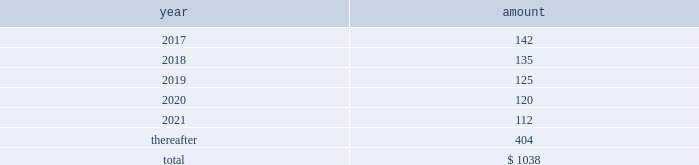Future payments that will not be paid because of an early redemption , which is discounted at a fixed spread over a comparable treasury security .
The unamortized discount and debt issuance costs are being amortized over the remaining term of the 2022 notes .
2021 notes .
In may 2011 , the company issued $ 1.5 billion in aggregate principal amount of unsecured unsubordinated obligations .
These notes were issued as two separate series of senior debt securities , including $ 750 million of 4.25% ( 4.25 % ) notes maturing in may 2021 and $ 750 million of floating rate notes , which were repaid in may 2013 at maturity .
Net proceeds of this offering were used to fund the repurchase of blackrock 2019s series b preferred from affiliates of merrill lynch & co. , inc .
Interest on the 4.25% ( 4.25 % ) notes due in 2021 ( 201c2021 notes 201d ) is payable semi-annually on may 24 and november 24 of each year , which commenced november 24 , 2011 , and is approximately $ 32 million per year .
The 2021 notes may be redeemed prior to maturity at any time in whole or in part at the option of the company at a 201cmake-whole 201d redemption price .
The unamortized discount and debt issuance costs are being amortized over the remaining term of the 2021 notes .
2019 notes .
In december 2009 , the company issued $ 2.5 billion in aggregate principal amount of unsecured and unsubordinated obligations .
These notes were issued as three separate series of senior debt securities including $ 0.5 billion of 2.25% ( 2.25 % ) notes , which were repaid in december 2012 , $ 1.0 billion of 3.50% ( 3.50 % ) notes , which were repaid in december 2014 at maturity , and $ 1.0 billion of 5.0% ( 5.0 % ) notes maturing in december 2019 ( the 201c2019 notes 201d ) .
Net proceeds of this offering were used to repay borrowings under the cp program , which was used to finance a portion of the acquisition of barclays global investors from barclays on december 1 , 2009 , and for general corporate purposes .
Interest on the 2019 notes of approximately $ 50 million per year is payable semi-annually in arrears on june 10 and december 10 of each year .
These notes may be redeemed prior to maturity at any time in whole or in part at the option of the company at a 201cmake-whole 201d redemption price .
The unamortized discount and debt issuance costs are being amortized over the remaining term of the 2019 notes .
2017 notes .
In september 2007 , the company issued $ 700 million in aggregate principal amount of 6.25% ( 6.25 % ) senior unsecured and unsubordinated notes maturing on september 15 , 2017 ( the 201c2017 notes 201d ) .
A portion of the net proceeds of the 2017 notes was used to fund the initial cash payment for the acquisition of the fund-of-funds business of quellos and the remainder was used for general corporate purposes .
Interest is payable semi-annually in arrears on march 15 and september 15 of each year , or approximately $ 44 million per year .
The 2017 notes may be redeemed prior to maturity at any time in whole or in part at the option of the company at a 201cmake-whole 201d redemption price .
The unamortized discount and debt issuance costs are being amortized over the remaining term of the 2017 notes .
13 .
Commitments and contingencies operating lease commitments the company leases its primary office spaces under agreements that expire through 2035 .
Future minimum commitments under these operating leases are as follows : ( in millions ) .
Rent expense and certain office equipment expense under lease agreements amounted to $ 134 million , $ 136 million and $ 132 million in 2016 , 2015 and 2014 , respectively .
Investment commitments .
At december 31 , 2016 , the company had $ 192 million of various capital commitments to fund sponsored investment funds , including consolidated vies .
These funds include private equity funds , real assets funds , and opportunistic funds .
This amount excludes additional commitments made by consolidated funds of funds to underlying third-party funds as third-party noncontrolling interest holders have the legal obligation to fund the respective commitments of such funds of funds .
In addition to the capital commitments of $ 192 million , the company had approximately $ 12 million of contingent commitments for certain funds which have investment periods that have expired .
Generally , the timing of the funding of these commitments is unknown and the commitments are callable on demand at any time prior to the expiration of the commitment .
These unfunded commitments are not recorded on the consolidated statements of financial condition .
These commitments do not include potential future commitments approved by the company that are not yet legally binding .
The company intends to make additional capital commitments from time to time to fund additional investment products for , and with , its clients .
Contingencies contingent payments related to business acquisitions .
In connection with certain acquisitions , blackrock is required to make contingent payments , subject to achieving specified performance targets , which may include revenue related to acquired contracts or new capital commitments for certain products .
The fair value of the remaining aggregate contingent payments at december 31 , 2016 totaled $ 115 million and is included in other liabilities on the consolidated statement of financial condition .
Other contingent payments .
The company acts as the portfolio manager in a series of derivative transactions and has a maximum potential exposure of $ 17 million between the company and counterparty .
See note 7 , derivatives and hedging , for further discussion .
Legal proceedings .
From time to time , blackrock receives subpoenas or other requests for information from various u.s .
Federal , state governmental and domestic and international regulatory authorities in connection with .
What is the expected percentage change in rent expense and certain office equipment expense from 2017 to 2018? 
Computations: ((135 - 142) / 142)
Answer: -0.0493. 